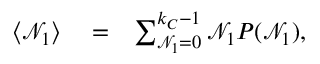Convert formula to latex. <formula><loc_0><loc_0><loc_500><loc_500>\begin{array} { r l r } { \langle \mathcal { N } _ { 1 } \rangle } & = } & { \sum _ { \mathcal { N } _ { 1 } = 0 } ^ { k _ { C } - 1 } \mathcal { N } _ { 1 } P ( \mathcal { N } _ { 1 } ) , } \end{array}</formula> 